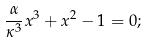Convert formula to latex. <formula><loc_0><loc_0><loc_500><loc_500>\frac { \alpha } { \kappa ^ { 3 } } x ^ { 3 } + x ^ { 2 } - 1 = 0 ;</formula> 